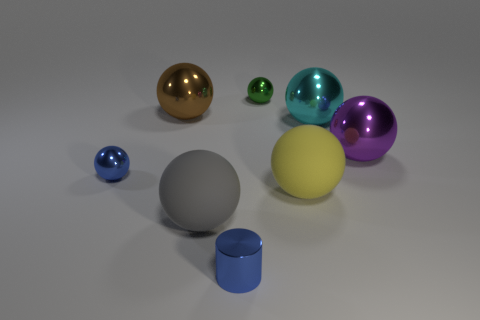Subtract 4 spheres. How many spheres are left? 3 Subtract all purple balls. How many balls are left? 6 Subtract all brown balls. How many balls are left? 6 Add 1 big metallic cubes. How many objects exist? 9 Subtract all cyan balls. Subtract all cyan cubes. How many balls are left? 6 Subtract all cylinders. How many objects are left? 7 Add 7 blue shiny balls. How many blue shiny balls exist? 8 Subtract 0 red blocks. How many objects are left? 8 Subtract all purple balls. Subtract all green metal objects. How many objects are left? 6 Add 4 large cyan spheres. How many large cyan spheres are left? 5 